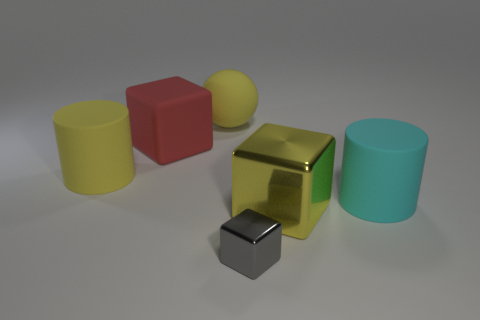Subtract all big blocks. How many blocks are left? 1 Add 1 small gray metallic things. How many objects exist? 7 Subtract all yellow blocks. How many blocks are left? 2 Subtract all cylinders. How many objects are left? 4 Subtract 1 cylinders. How many cylinders are left? 1 Subtract all cyan cylinders. Subtract all brown spheres. How many cylinders are left? 1 Subtract all blue balls. How many gray cylinders are left? 0 Subtract all blocks. Subtract all cyan things. How many objects are left? 2 Add 6 large cyan cylinders. How many large cyan cylinders are left? 7 Add 5 yellow metal things. How many yellow metal things exist? 6 